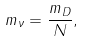<formula> <loc_0><loc_0><loc_500><loc_500>m _ { \nu } = \frac { m _ { D } } { N } ,</formula> 